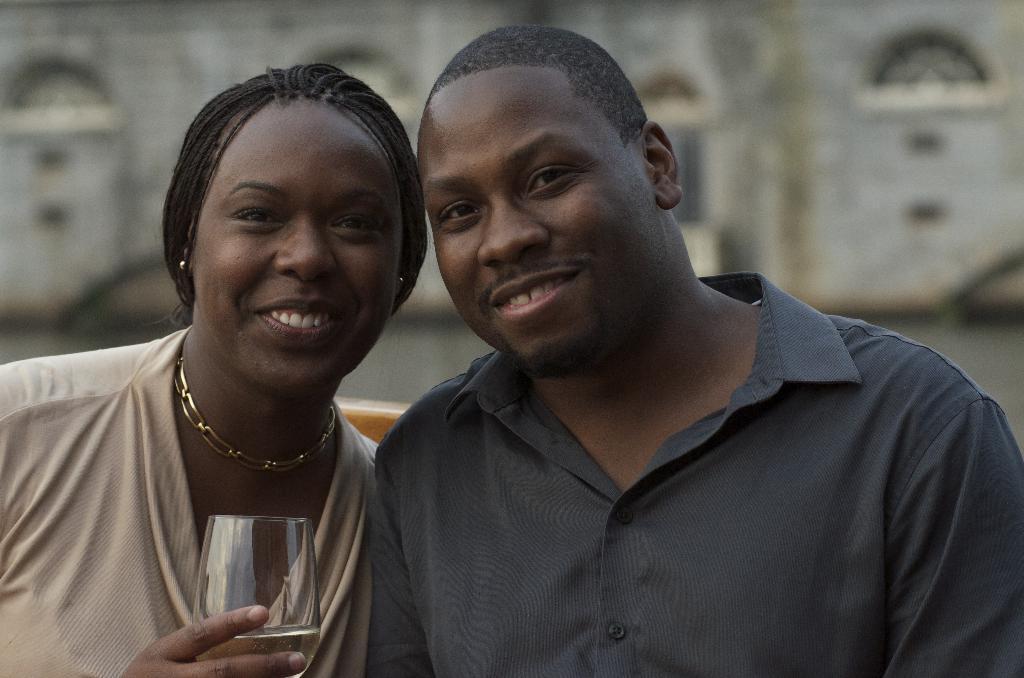Please provide a concise description of this image. In this image we can see there is a boy and a girl with a smile on their face and the girl holding a glass of drink. The background is blurred. 